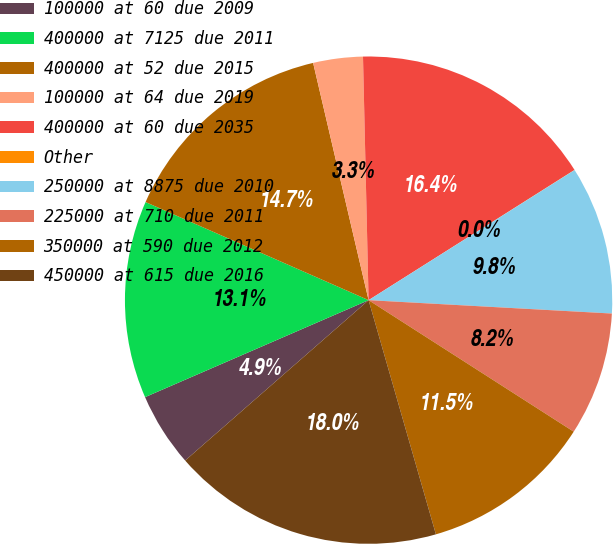<chart> <loc_0><loc_0><loc_500><loc_500><pie_chart><fcel>100000 at 60 due 2009<fcel>400000 at 7125 due 2011<fcel>400000 at 52 due 2015<fcel>100000 at 64 due 2019<fcel>400000 at 60 due 2035<fcel>Other<fcel>250000 at 8875 due 2010<fcel>225000 at 710 due 2011<fcel>350000 at 590 due 2012<fcel>450000 at 615 due 2016<nl><fcel>4.92%<fcel>13.11%<fcel>14.75%<fcel>3.29%<fcel>16.39%<fcel>0.01%<fcel>9.84%<fcel>8.2%<fcel>11.47%<fcel>18.02%<nl></chart> 